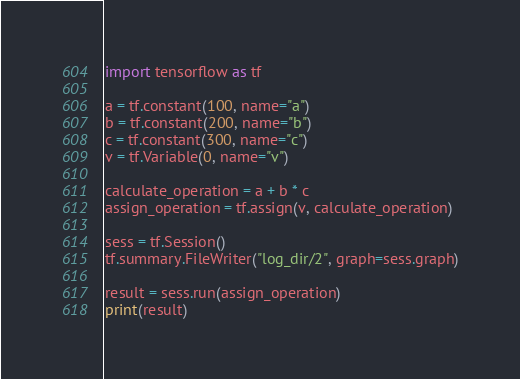<code> <loc_0><loc_0><loc_500><loc_500><_Python_>import tensorflow as tf

a = tf.constant(100, name="a")
b = tf.constant(200, name="b")
c = tf.constant(300, name="c")
v = tf.Variable(0, name="v")

calculate_operation = a + b * c
assign_operation = tf.assign(v, calculate_operation)

sess = tf.Session()
tf.summary.FileWriter("log_dir/2", graph=sess.graph)

result = sess.run(assign_operation)
print(result)
</code> 